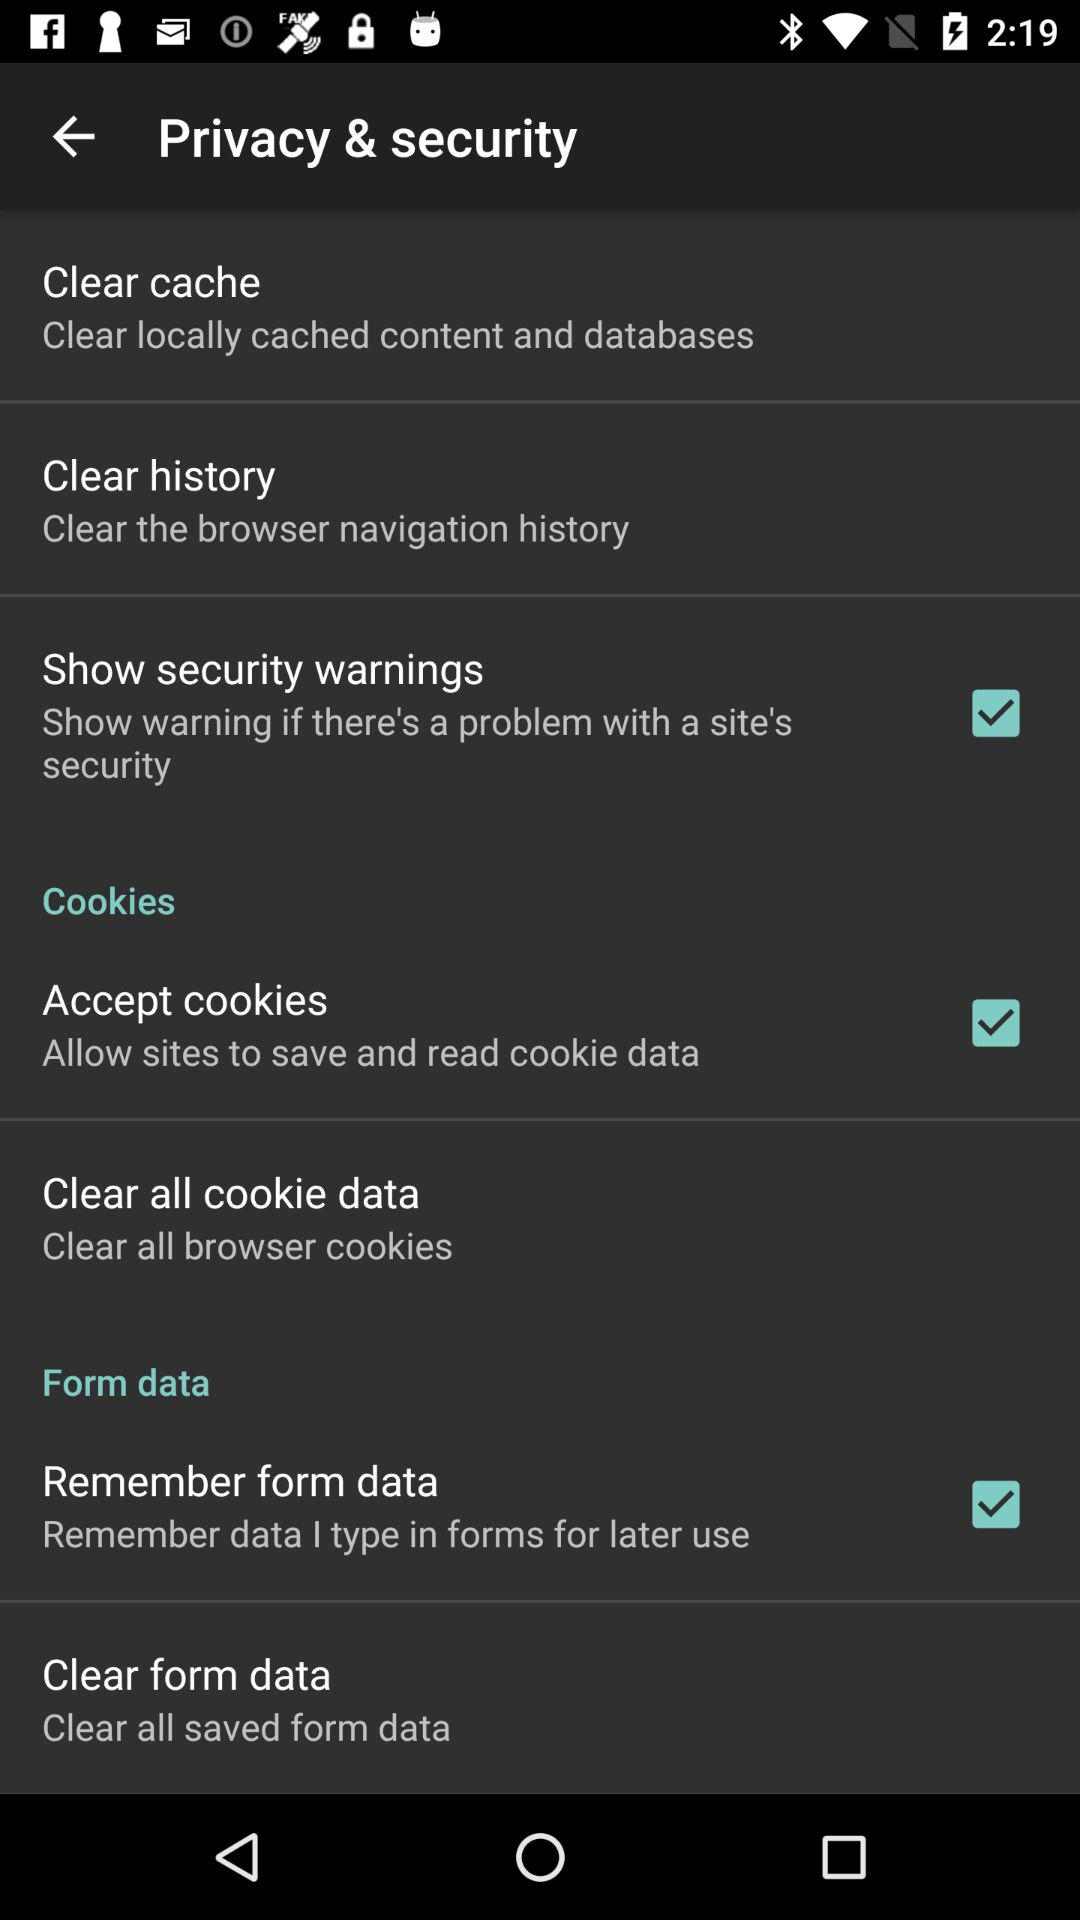When will the user be warned about security? The user will be warned about security if there's a problem with a site's security. 